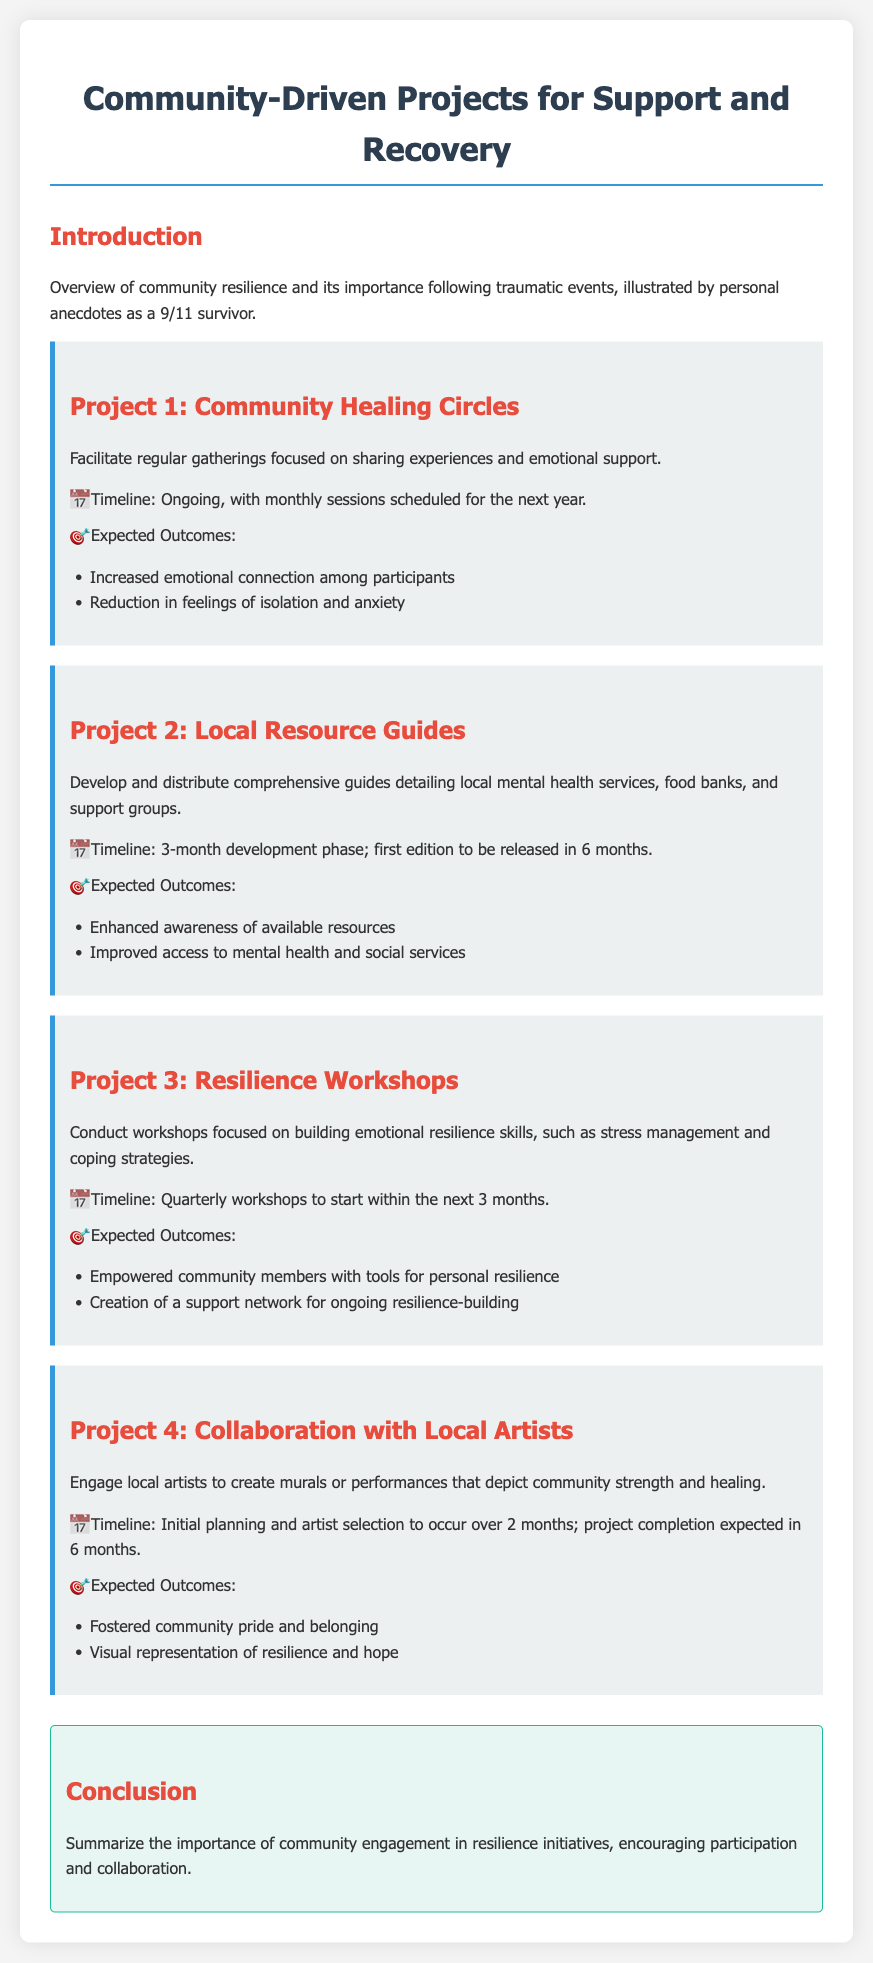what is the title of the document? The title of the document is provided at the beginning, which is "Community-Driven Projects for Support and Recovery."
Answer: Community-Driven Projects for Support and Recovery how many community projects are detailed in the document? The document lists four separate community-driven projects focused on support and recovery.
Answer: Four what is the timeline for the first project? The first project's timeline for Community Healing Circles is described as ongoing, with monthly sessions scheduled for the next year.
Answer: Ongoing, with monthly sessions scheduled for the next year what is one expected outcome of the Resilience Workshops? The expected outcomes for Resilience Workshops include tools for personal resilience, one of which is described clearly as empowerment.
Answer: Empowered community members with tools for personal resilience how long is the development phase for the Local Resource Guides? The document specifies a 3-month development phase for the Local Resource Guides before the first edition is released.
Answer: 3-month which project aims to create a visual representation of resilience? The project that engages local artists to create murals or performances is focused on depicting community strength and healing visually.
Answer: Collaboration with Local Artists what is the main goal of the Community Healing Circles? The primary goal of the Community Healing Circles is focused on sharing experiences and providing emotional support.
Answer: Sharing experiences and emotional support when will the first Resilience Workshop start? According to the document, the first Resilience Workshop is to be conducted quarterly, starting within the next 3 months.
Answer: Within the next 3 months what should be summarized in the conclusion section? The conclusion section emphasizes the importance of community engagement in resilience initiatives, prompting active participation.
Answer: Importance of community engagement in resilience initiatives 